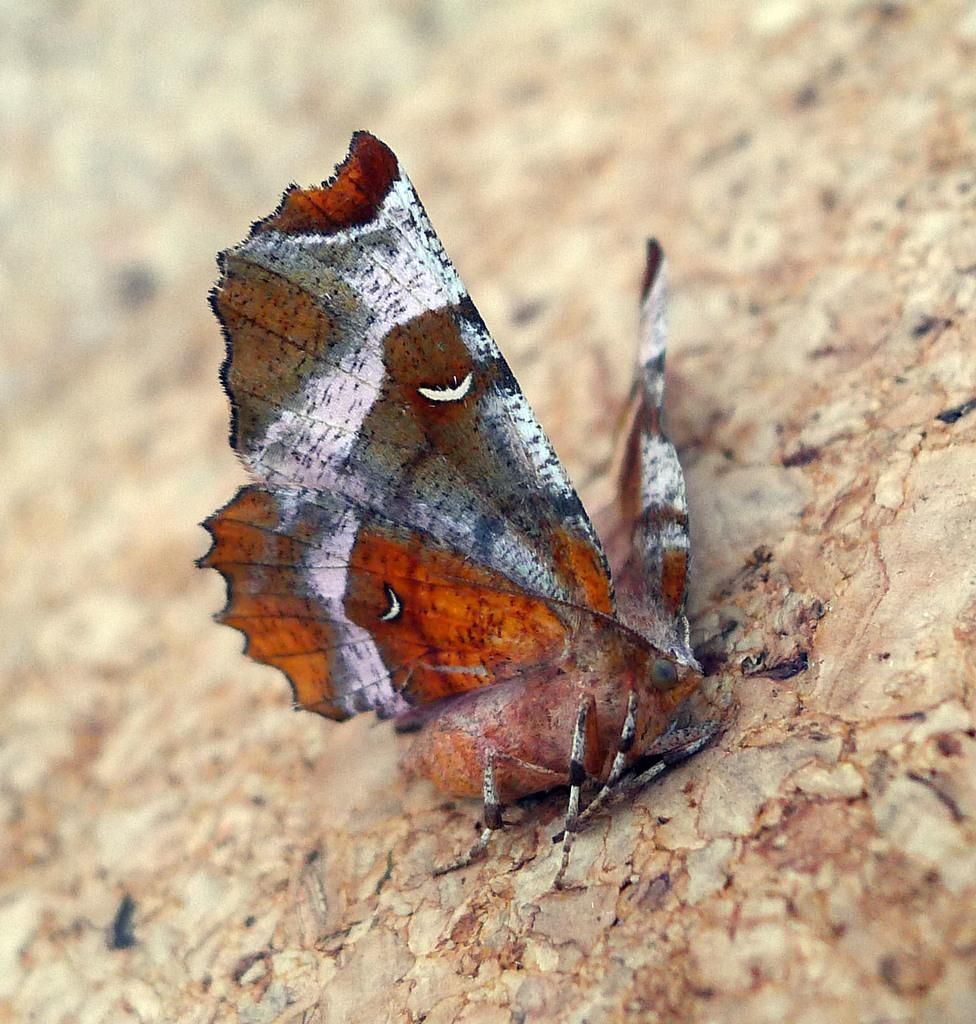What is the main subject of the image? There is a butterfly in the image. Where is the butterfly located? The butterfly is on a rock. How many apples are on the rock with the butterfly? There are no apples present in the image; it only features a butterfly on a rock. Is there a cat visible in the image? There is no cat present in the image. 